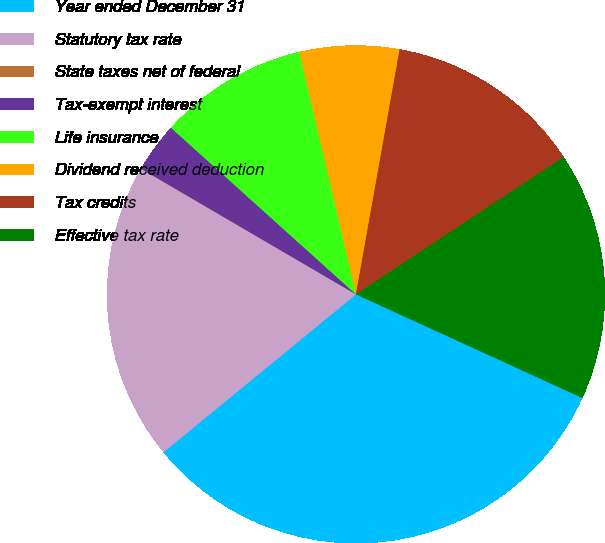Convert chart. <chart><loc_0><loc_0><loc_500><loc_500><pie_chart><fcel>Year ended December 31<fcel>Statutory tax rate<fcel>State taxes net of federal<fcel>Tax-exempt interest<fcel>Life insurance<fcel>Dividend received deduction<fcel>Tax credits<fcel>Effective tax rate<nl><fcel>32.23%<fcel>19.34%<fcel>0.02%<fcel>3.24%<fcel>9.68%<fcel>6.46%<fcel>12.9%<fcel>16.12%<nl></chart> 